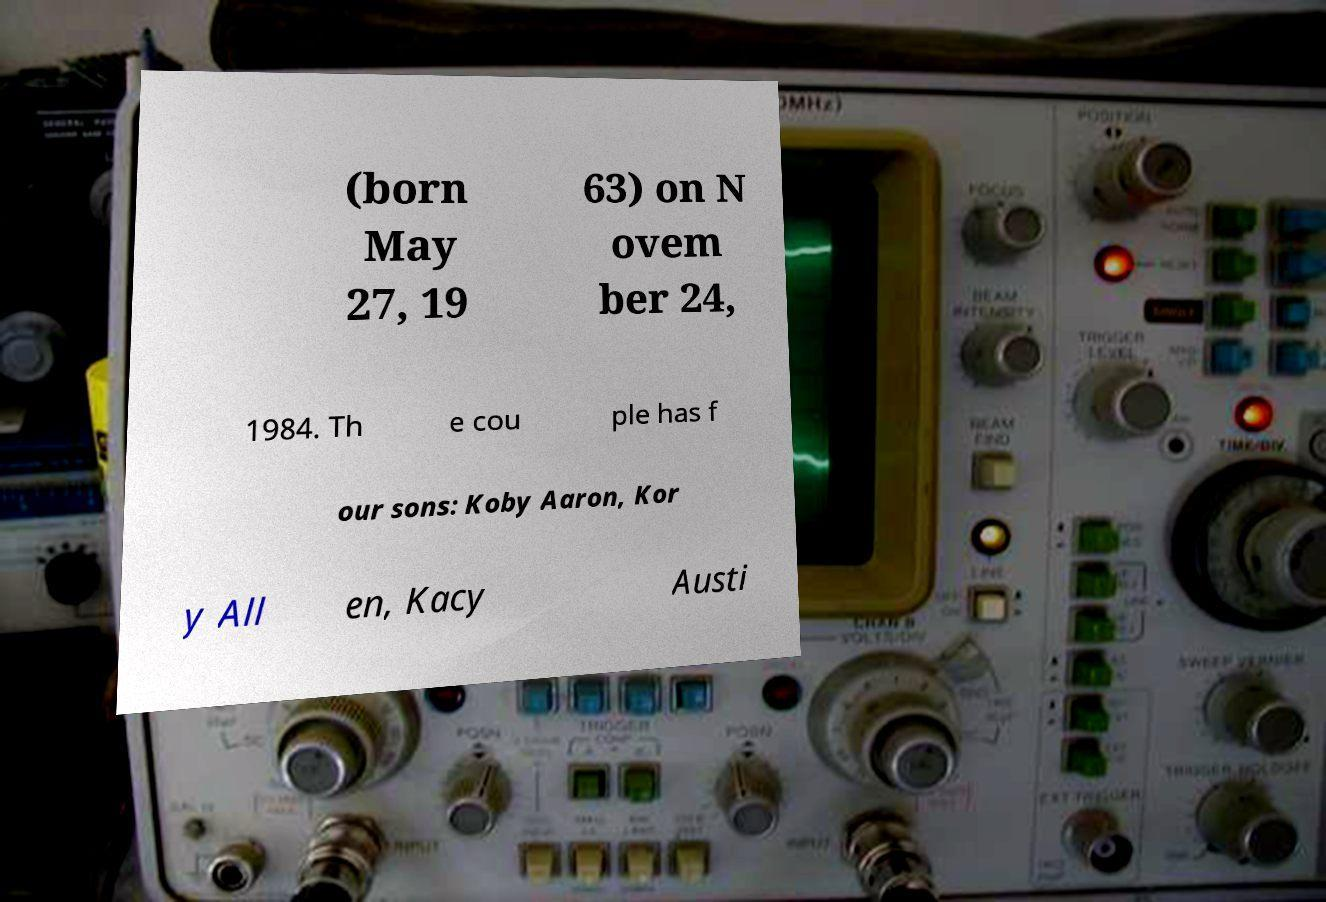There's text embedded in this image that I need extracted. Can you transcribe it verbatim? (born May 27, 19 63) on N ovem ber 24, 1984. Th e cou ple has f our sons: Koby Aaron, Kor y All en, Kacy Austi 